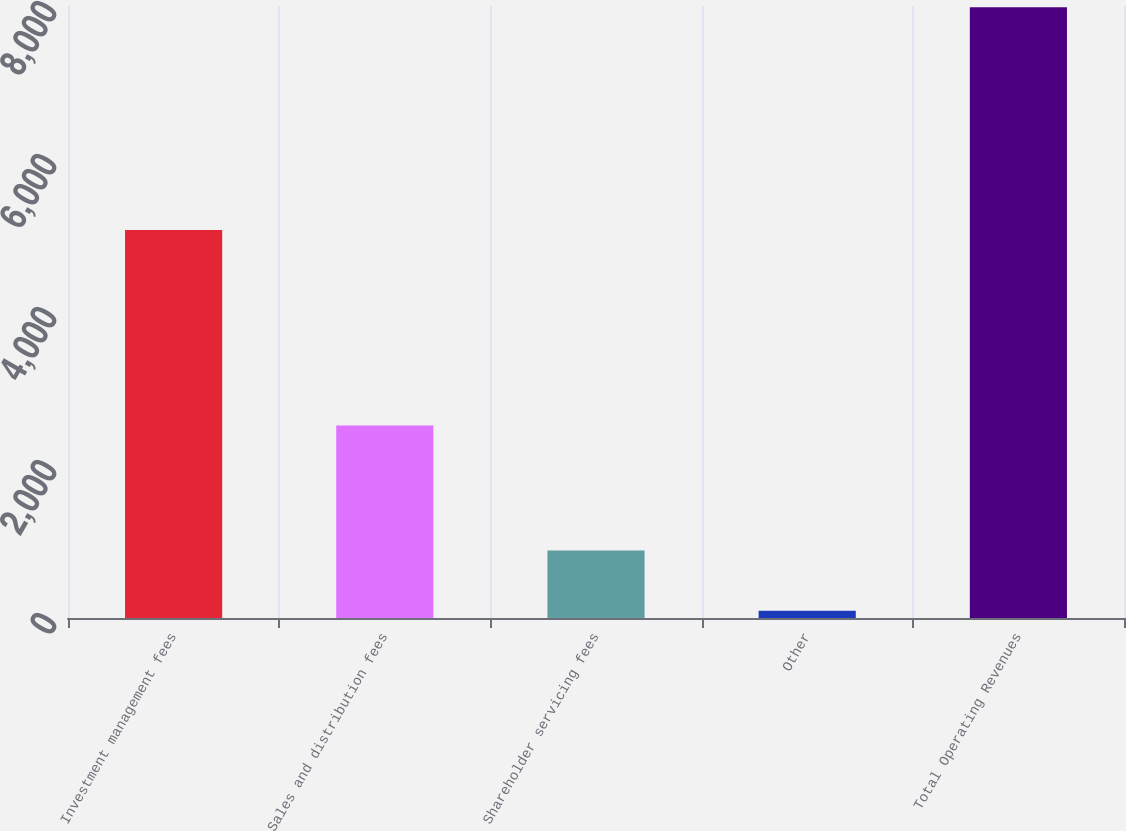<chart> <loc_0><loc_0><loc_500><loc_500><bar_chart><fcel>Investment management fees<fcel>Sales and distribution fees<fcel>Shareholder servicing fees<fcel>Other<fcel>Total Operating Revenues<nl><fcel>5071.4<fcel>2516<fcel>883.01<fcel>93.9<fcel>7985<nl></chart> 